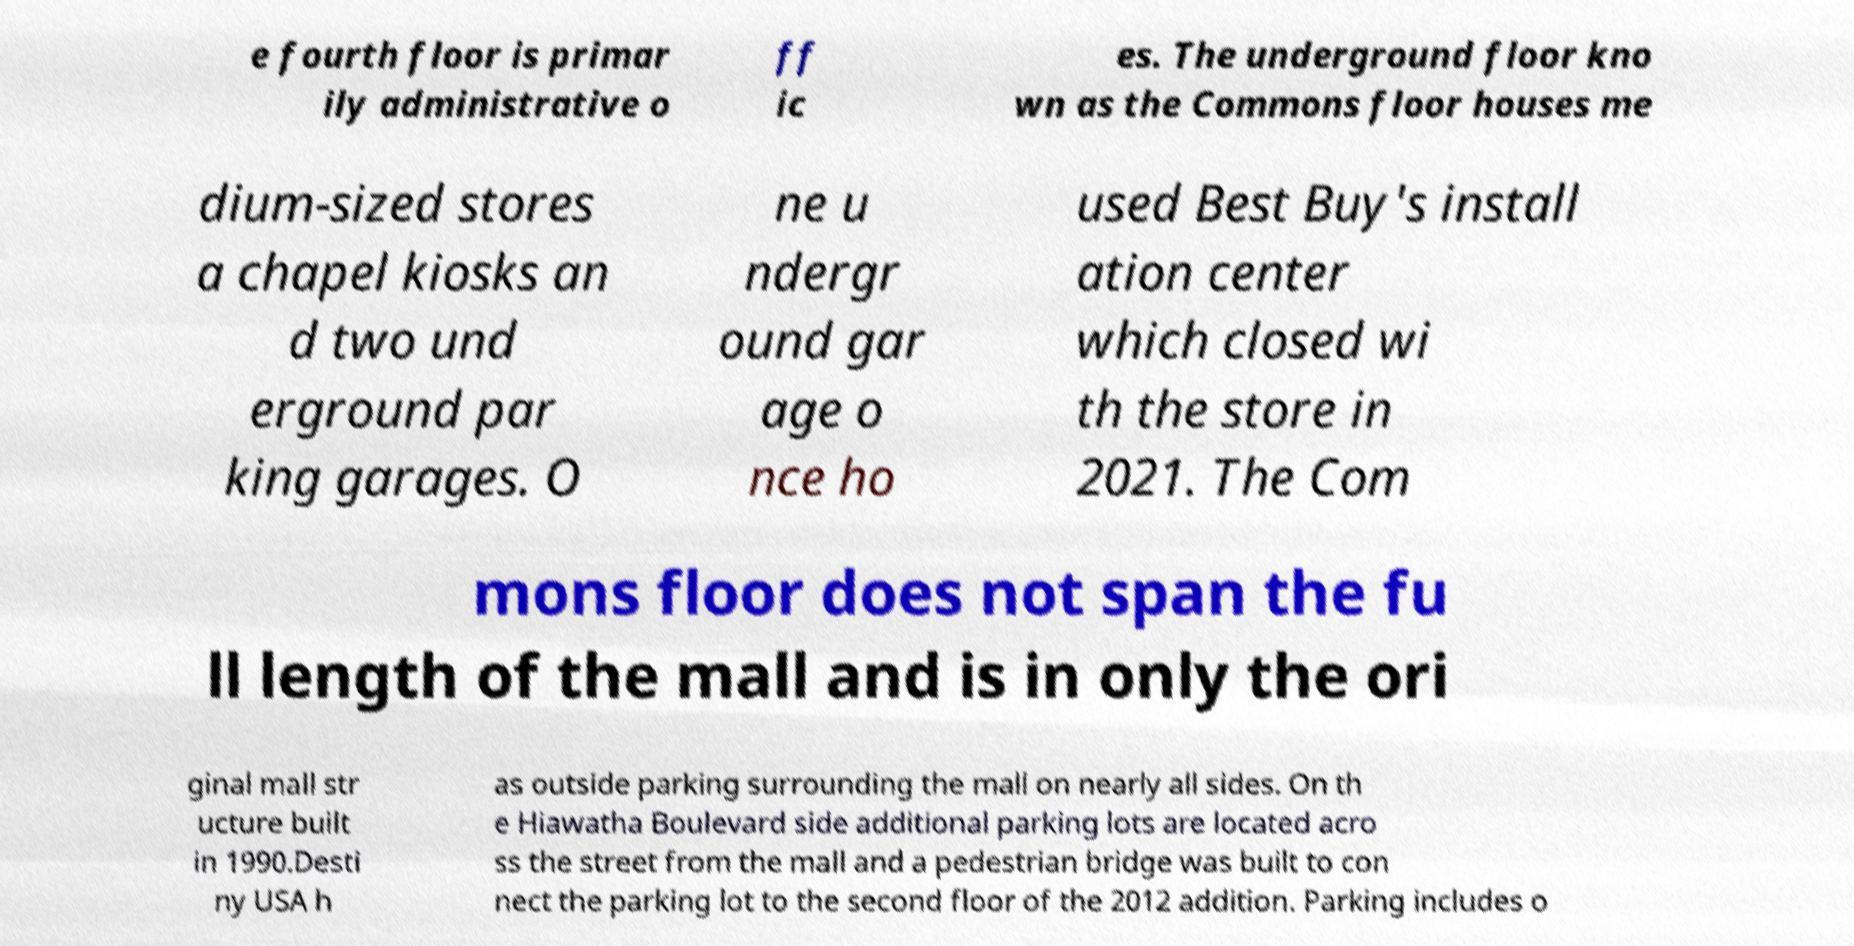There's text embedded in this image that I need extracted. Can you transcribe it verbatim? e fourth floor is primar ily administrative o ff ic es. The underground floor kno wn as the Commons floor houses me dium-sized stores a chapel kiosks an d two und erground par king garages. O ne u ndergr ound gar age o nce ho used Best Buy's install ation center which closed wi th the store in 2021. The Com mons floor does not span the fu ll length of the mall and is in only the ori ginal mall str ucture built in 1990.Desti ny USA h as outside parking surrounding the mall on nearly all sides. On th e Hiawatha Boulevard side additional parking lots are located acro ss the street from the mall and a pedestrian bridge was built to con nect the parking lot to the second floor of the 2012 addition. Parking includes o 